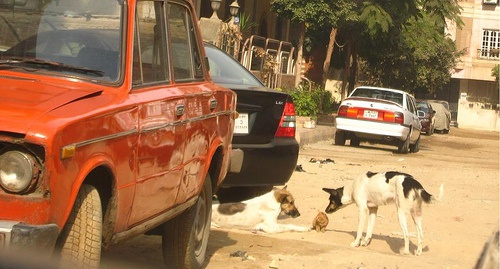Describe the objects in this image and their specific colors. I can see car in gray, brown, and red tones, car in gray, black, and darkgray tones, dog in gray, khaki, lightyellow, black, and tan tones, car in gray, ivory, and black tones, and dog in gray, lightyellow, khaki, tan, and olive tones in this image. 